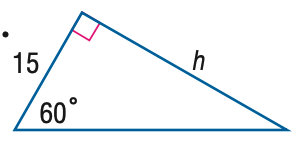Answer the mathemtical geometry problem and directly provide the correct option letter.
Question: Find h.
Choices: A: \frac { 15 \sqrt { 3 } } { 2 } B: 15 C: 15 \sqrt 2 D: 15 \sqrt 3 D 